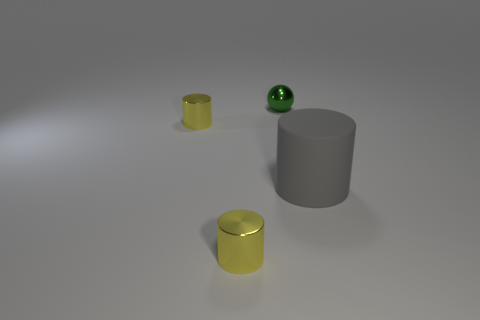Subtract all small yellow cylinders. How many cylinders are left? 1 Subtract 1 balls. How many balls are left? 0 Add 3 big blue metallic blocks. How many objects exist? 7 Subtract all yellow cylinders. How many cylinders are left? 1 Add 4 metallic things. How many metallic things are left? 7 Add 4 small balls. How many small balls exist? 5 Subtract 0 purple cubes. How many objects are left? 4 Subtract all spheres. How many objects are left? 3 Subtract all blue cylinders. Subtract all blue balls. How many cylinders are left? 3 Subtract all red blocks. How many gray spheres are left? 0 